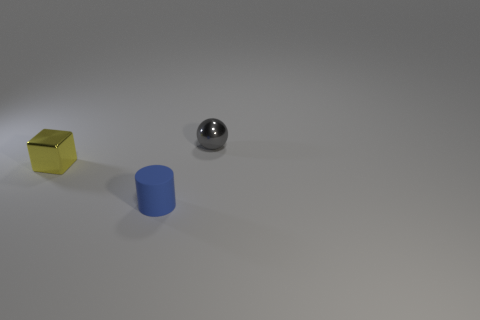Is there anything else that has the same material as the blue thing?
Offer a very short reply. No. How many gray things are in front of the cube?
Your response must be concise. 0. There is a small object that is in front of the shiny thing in front of the gray metallic ball; are there any small rubber cylinders that are in front of it?
Provide a succinct answer. No. What number of gray balls have the same size as the cylinder?
Your response must be concise. 1. The object right of the small object that is in front of the yellow cube is made of what material?
Keep it short and to the point. Metal. What shape is the small metal object behind the metallic object that is in front of the small object that is behind the yellow object?
Your answer should be very brief. Sphere. Is the shape of the tiny shiny thing left of the gray object the same as the metallic object behind the small yellow metal cube?
Provide a succinct answer. No. What number of other objects are the same material as the yellow block?
Your response must be concise. 1. What is the shape of the small yellow object that is made of the same material as the ball?
Ensure brevity in your answer.  Cube. Is the size of the gray shiny ball the same as the blue cylinder?
Make the answer very short. Yes. 